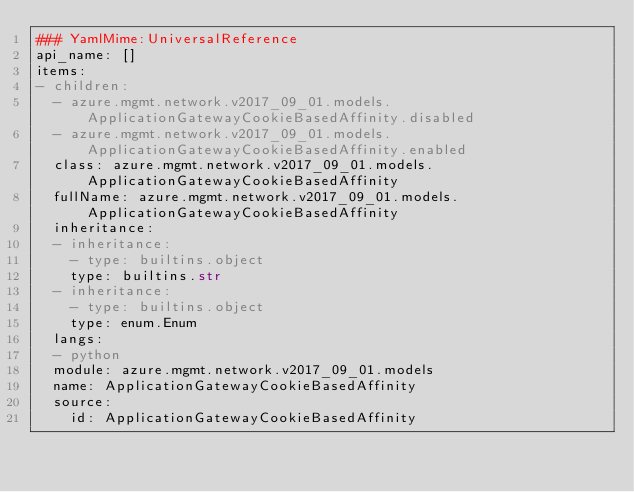<code> <loc_0><loc_0><loc_500><loc_500><_YAML_>### YamlMime:UniversalReference
api_name: []
items:
- children:
  - azure.mgmt.network.v2017_09_01.models.ApplicationGatewayCookieBasedAffinity.disabled
  - azure.mgmt.network.v2017_09_01.models.ApplicationGatewayCookieBasedAffinity.enabled
  class: azure.mgmt.network.v2017_09_01.models.ApplicationGatewayCookieBasedAffinity
  fullName: azure.mgmt.network.v2017_09_01.models.ApplicationGatewayCookieBasedAffinity
  inheritance:
  - inheritance:
    - type: builtins.object
    type: builtins.str
  - inheritance:
    - type: builtins.object
    type: enum.Enum
  langs:
  - python
  module: azure.mgmt.network.v2017_09_01.models
  name: ApplicationGatewayCookieBasedAffinity
  source:
    id: ApplicationGatewayCookieBasedAffinity</code> 